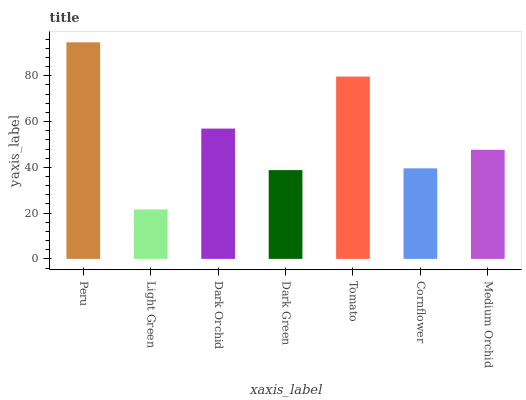Is Light Green the minimum?
Answer yes or no. Yes. Is Peru the maximum?
Answer yes or no. Yes. Is Dark Orchid the minimum?
Answer yes or no. No. Is Dark Orchid the maximum?
Answer yes or no. No. Is Dark Orchid greater than Light Green?
Answer yes or no. Yes. Is Light Green less than Dark Orchid?
Answer yes or no. Yes. Is Light Green greater than Dark Orchid?
Answer yes or no. No. Is Dark Orchid less than Light Green?
Answer yes or no. No. Is Medium Orchid the high median?
Answer yes or no. Yes. Is Medium Orchid the low median?
Answer yes or no. Yes. Is Peru the high median?
Answer yes or no. No. Is Light Green the low median?
Answer yes or no. No. 